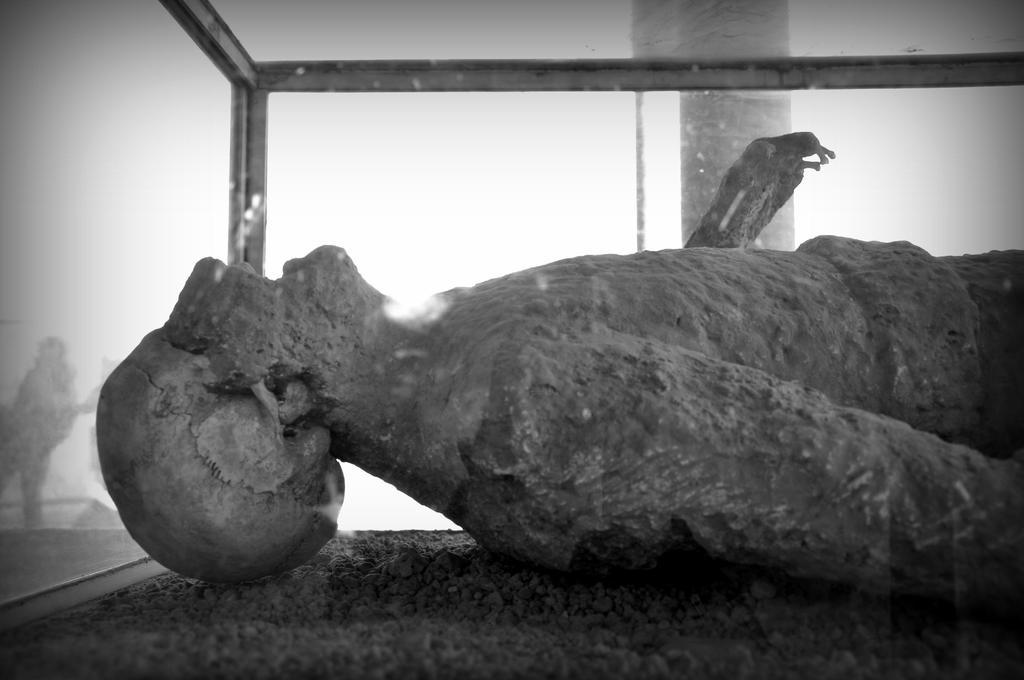What is the main subject of the image? There is a statue in the image. How is the statue displayed in the image? The statue is inside a glass box. What color is the background of the image? The background of the image is white. Can you see a boy playing near the river in the image? There is no boy or river present in the image; it features a statue inside a glass box with a white background. 